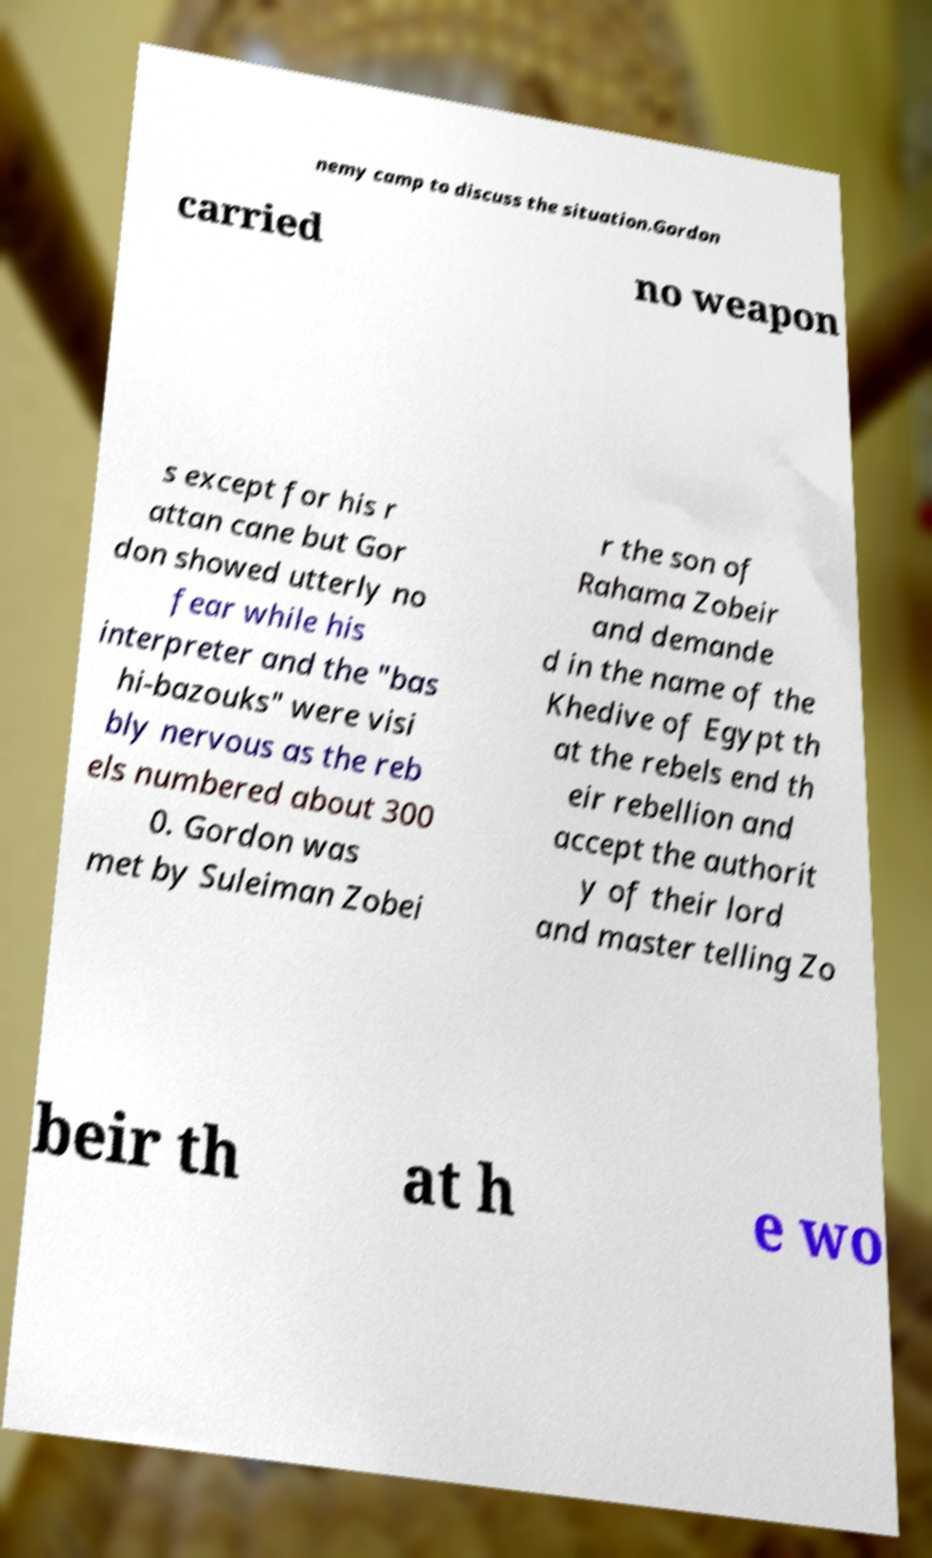Could you extract and type out the text from this image? nemy camp to discuss the situation.Gordon carried no weapon s except for his r attan cane but Gor don showed utterly no fear while his interpreter and the "bas hi-bazouks" were visi bly nervous as the reb els numbered about 300 0. Gordon was met by Suleiman Zobei r the son of Rahama Zobeir and demande d in the name of the Khedive of Egypt th at the rebels end th eir rebellion and accept the authorit y of their lord and master telling Zo beir th at h e wo 